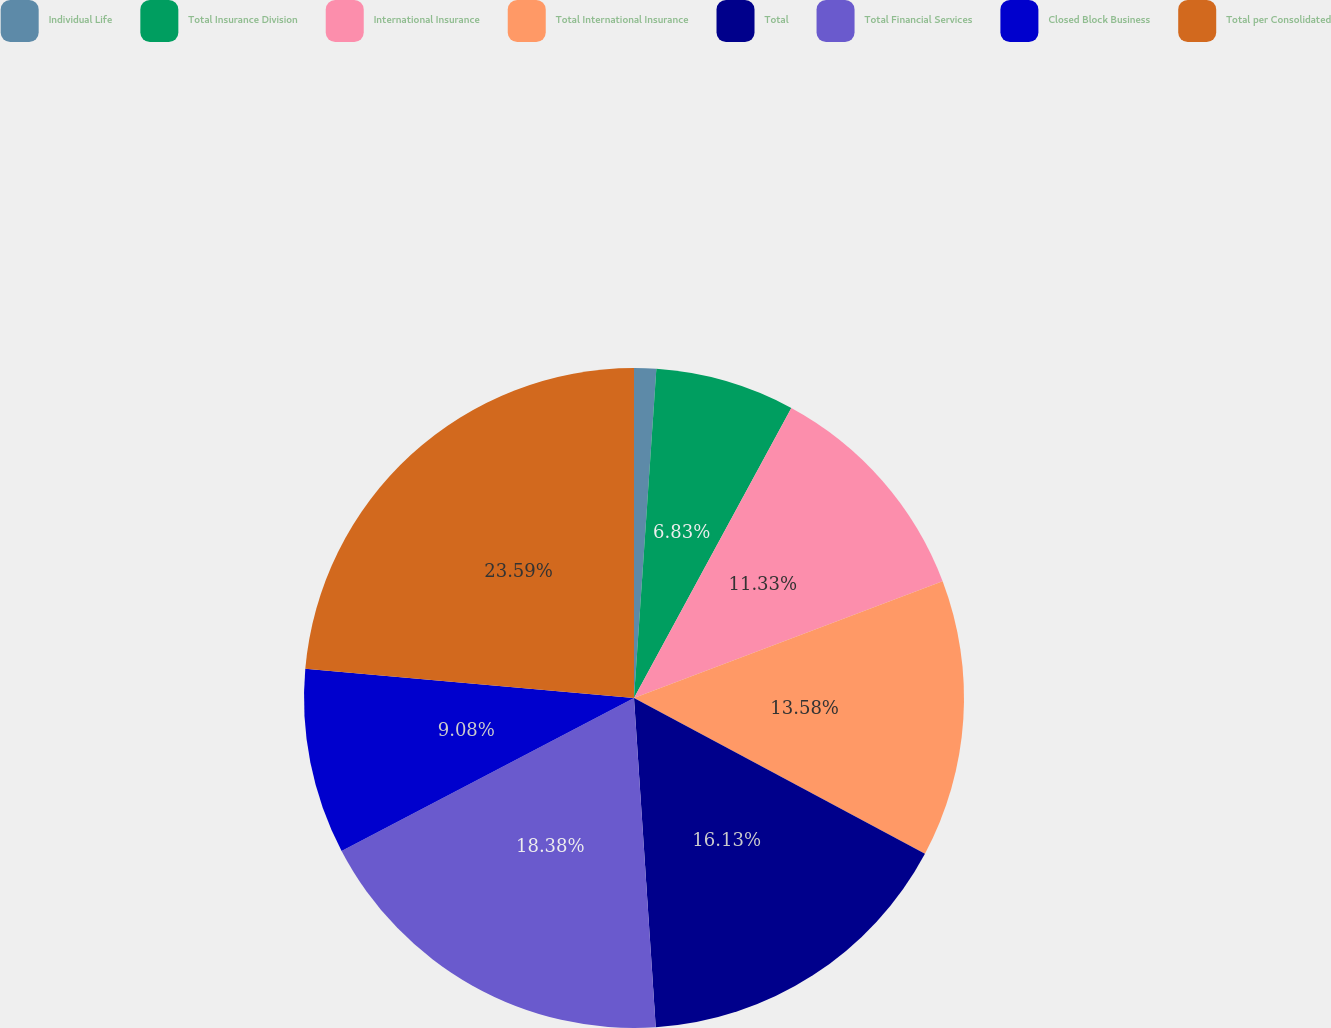Convert chart to OTSL. <chart><loc_0><loc_0><loc_500><loc_500><pie_chart><fcel>Individual Life<fcel>Total Insurance Division<fcel>International Insurance<fcel>Total International Insurance<fcel>Total<fcel>Total Financial Services<fcel>Closed Block Business<fcel>Total per Consolidated<nl><fcel>1.08%<fcel>6.83%<fcel>11.33%<fcel>13.58%<fcel>16.13%<fcel>18.38%<fcel>9.08%<fcel>23.59%<nl></chart> 